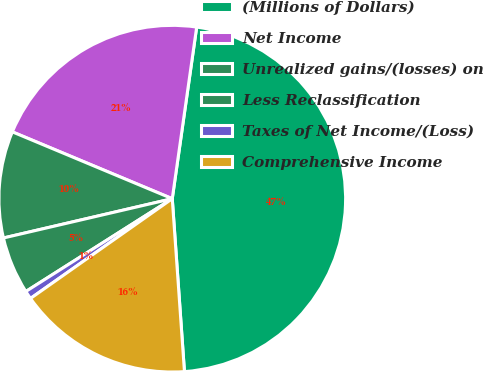Convert chart to OTSL. <chart><loc_0><loc_0><loc_500><loc_500><pie_chart><fcel>(Millions of Dollars)<fcel>Net Income<fcel>Unrealized gains/(losses) on<fcel>Less Reclassification<fcel>Taxes of Net Income/(Loss)<fcel>Comprehensive Income<nl><fcel>46.63%<fcel>20.95%<fcel>9.94%<fcel>5.35%<fcel>0.77%<fcel>16.36%<nl></chart> 